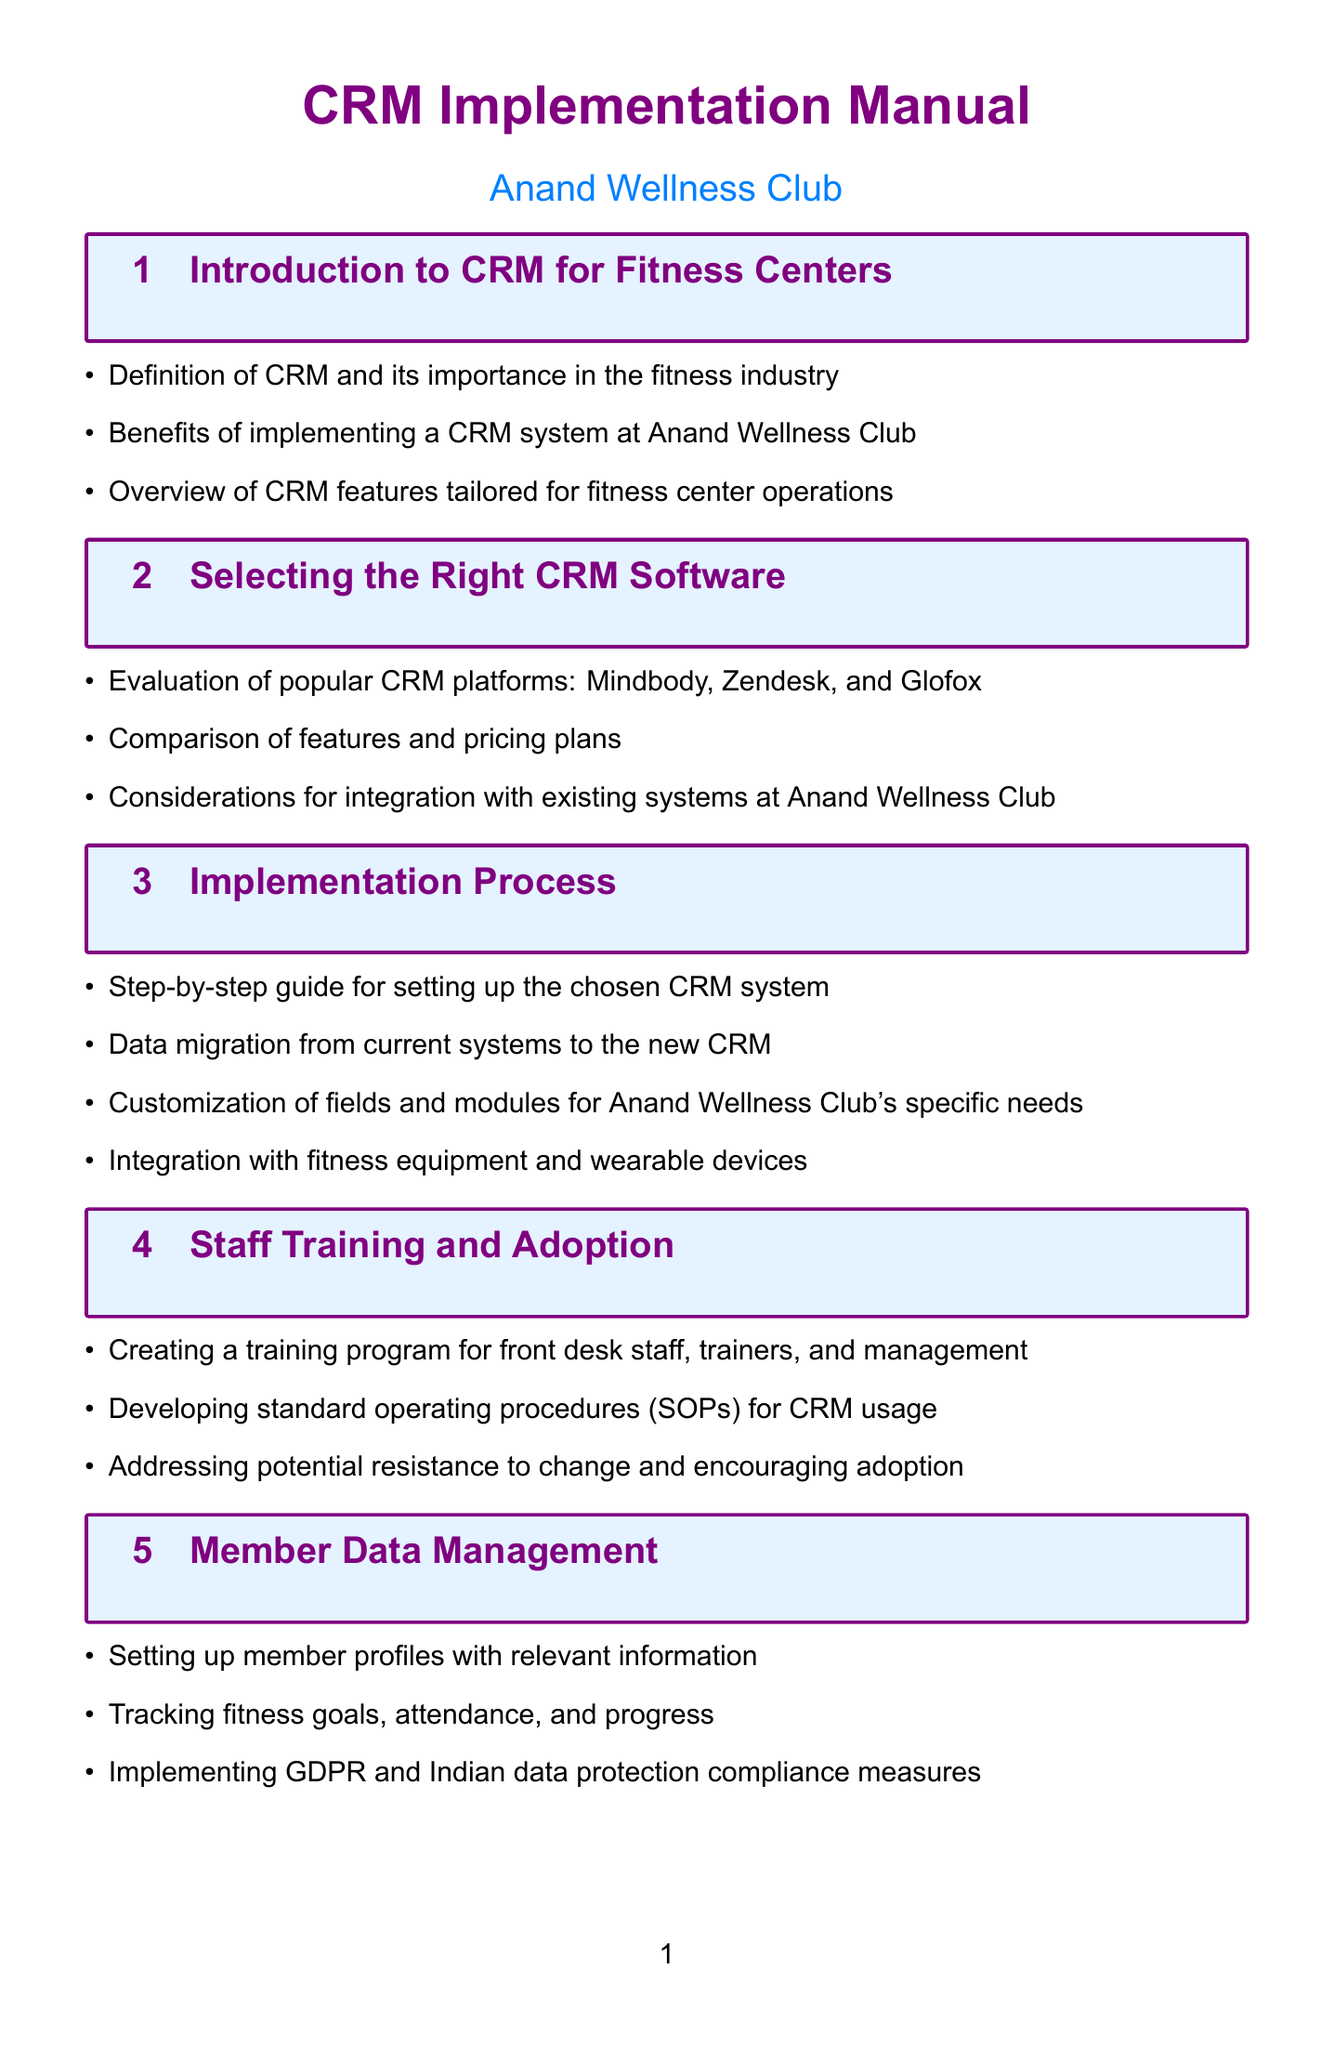What is the main focus of the document? The document is focused on implementing and managing a customer relationship management system for fitness center operations.
Answer: CRM Implementation Manual Which CRM platforms are evaluated? The section on selecting the right CRM software evaluates three popular CRM platforms.
Answer: Mindbody, Zendesk, Glofox What process is included for customizing the CRM? The implementation process section includes customization of fields and modules tailored for a specific fitness center's needs.
Answer: Customization of fields and modules What is a key benefit of using CRM for communication? Utilizing CRM enhances member engagement through targeted communication strategies.
Answer: Personalized email campaigns What information do member profiles track? Member data management involves tracking essential member information to monitor progress and engagement.
Answer: Fitness goals, attendance, and progress What type of billing integration is mentioned? The payment processing and billing section discusses integrating with various payment gateways for seamless transactions.
Answer: Razorpay and PayTM How are staff trained on the new system? The training program aims to educate staff on effective CRM usage and operational procedures.
Answer: Creating a training program What feedback mechanism is recommended? The document suggests creating automated satisfaction surveys to gauge member experience and satisfaction.
Answer: Automated satisfaction surveys What security measure is specified for the CRM? The security and access control section mentions implementing two-factor authentication for enhanced account security.
Answer: Two-factor authentication 